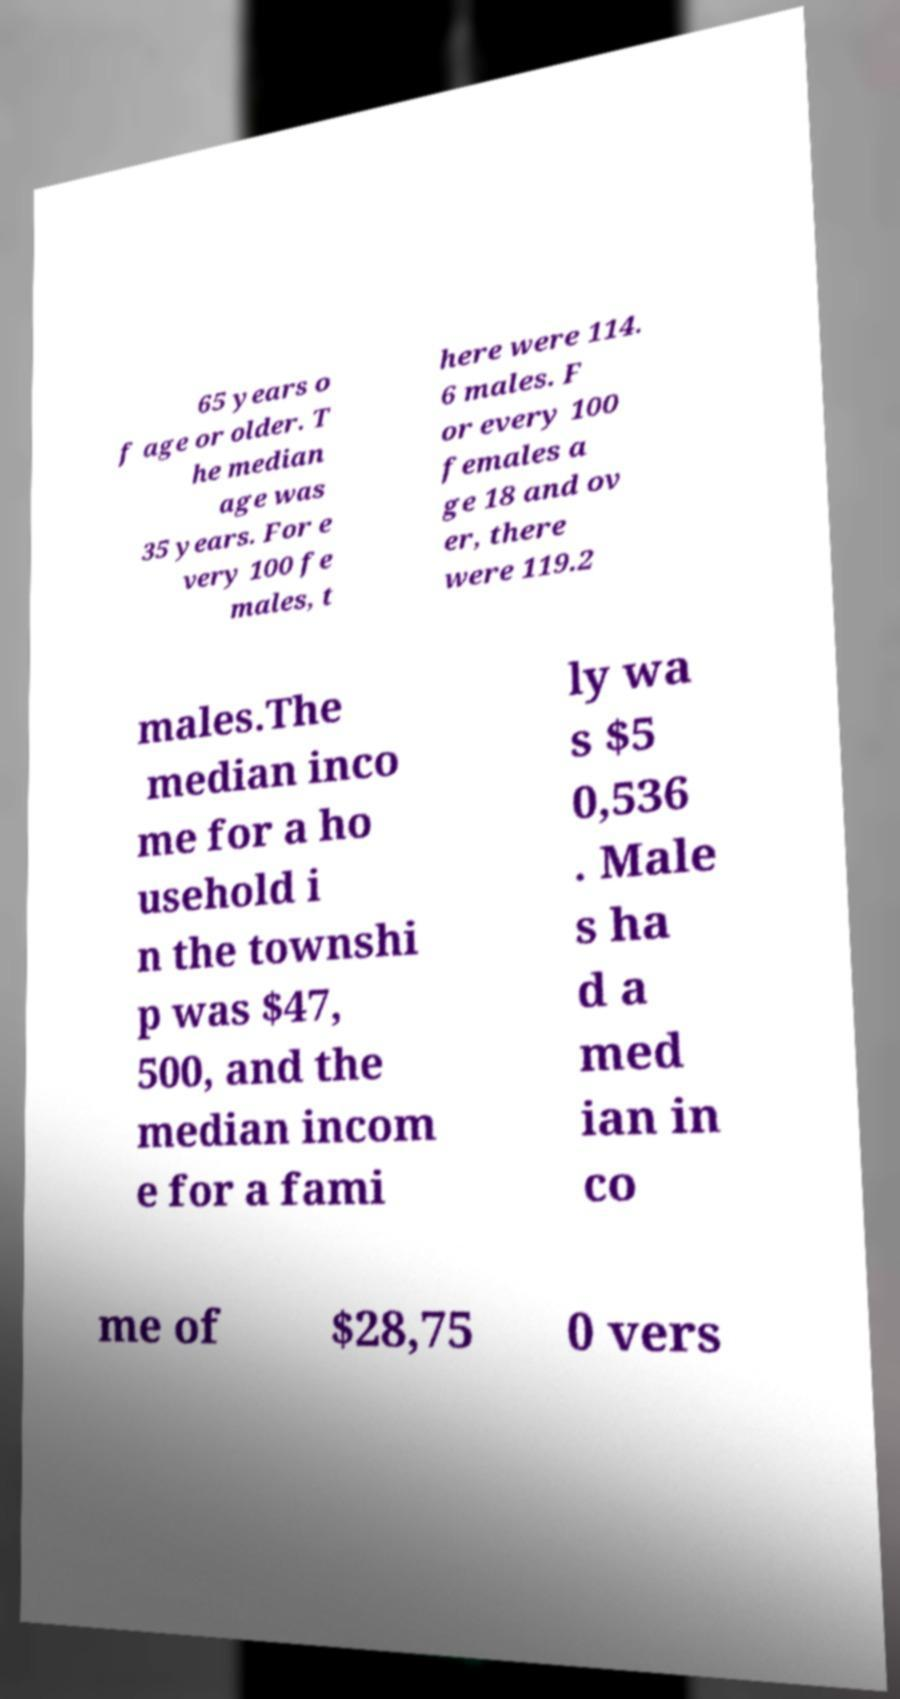Please identify and transcribe the text found in this image. 65 years o f age or older. T he median age was 35 years. For e very 100 fe males, t here were 114. 6 males. F or every 100 females a ge 18 and ov er, there were 119.2 males.The median inco me for a ho usehold i n the townshi p was $47, 500, and the median incom e for a fami ly wa s $5 0,536 . Male s ha d a med ian in co me of $28,75 0 vers 